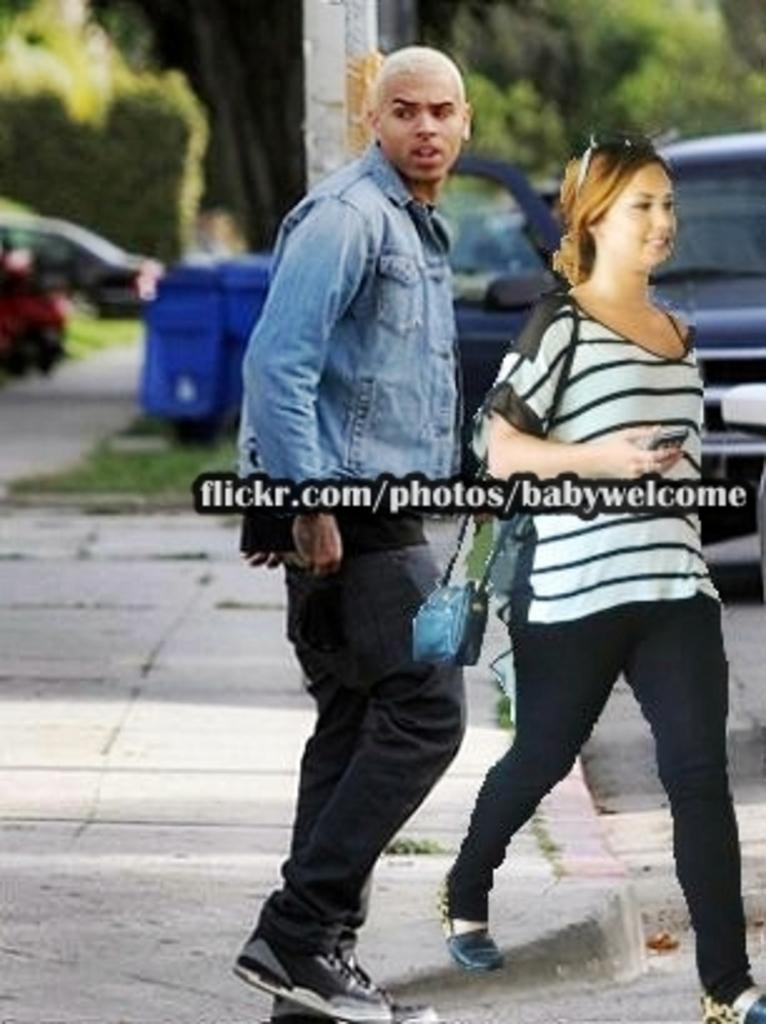<image>
Summarize the visual content of the image. A man and a woman are walking down the sidewalk while the man looks to his right. 